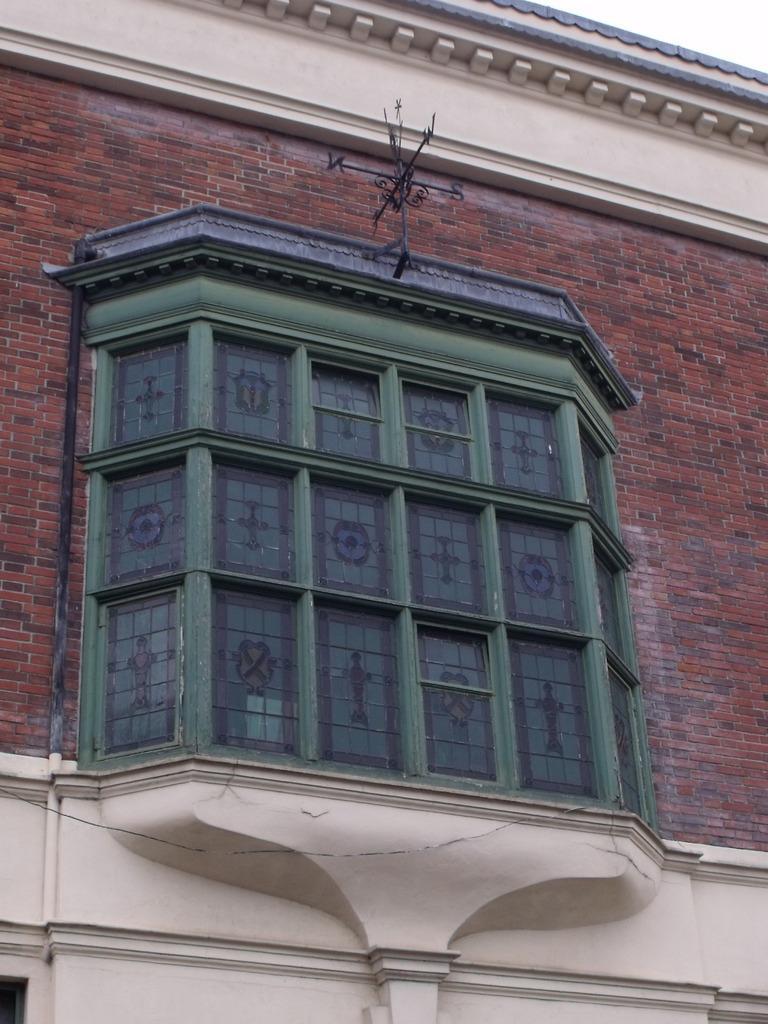Describe this image in one or two sentences. In this picture I can see there is a building and there is a window here. 